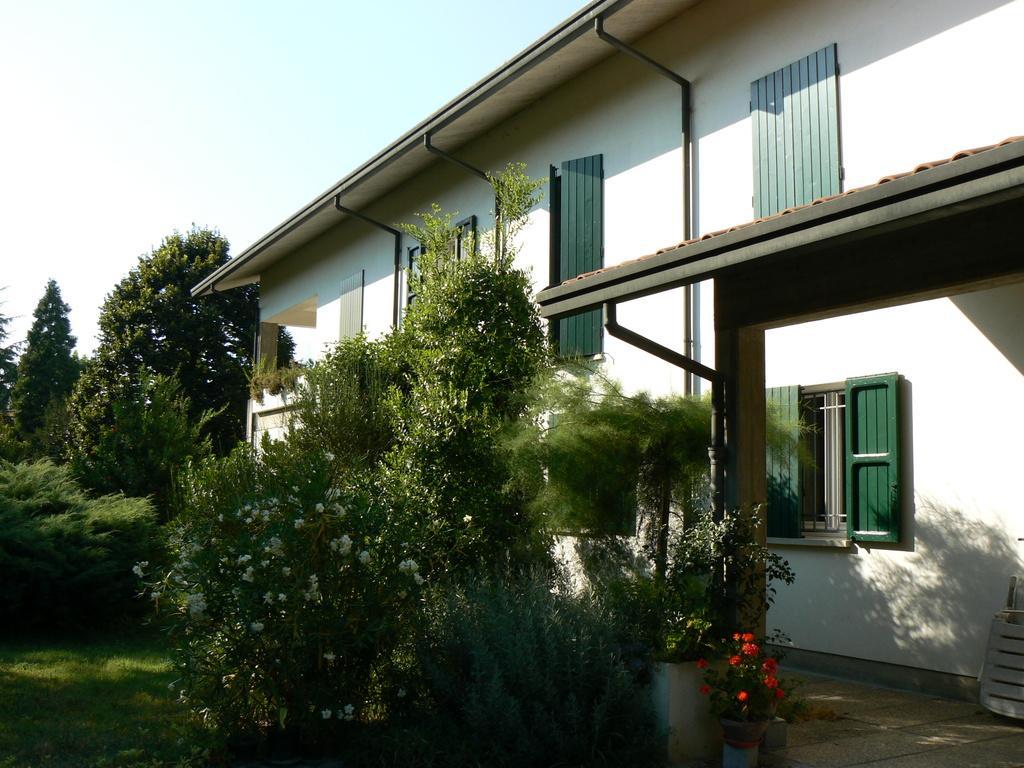In one or two sentences, can you explain what this image depicts? In this image we can see flower pots, small plants, house, trees, grass and the sky in the background. 